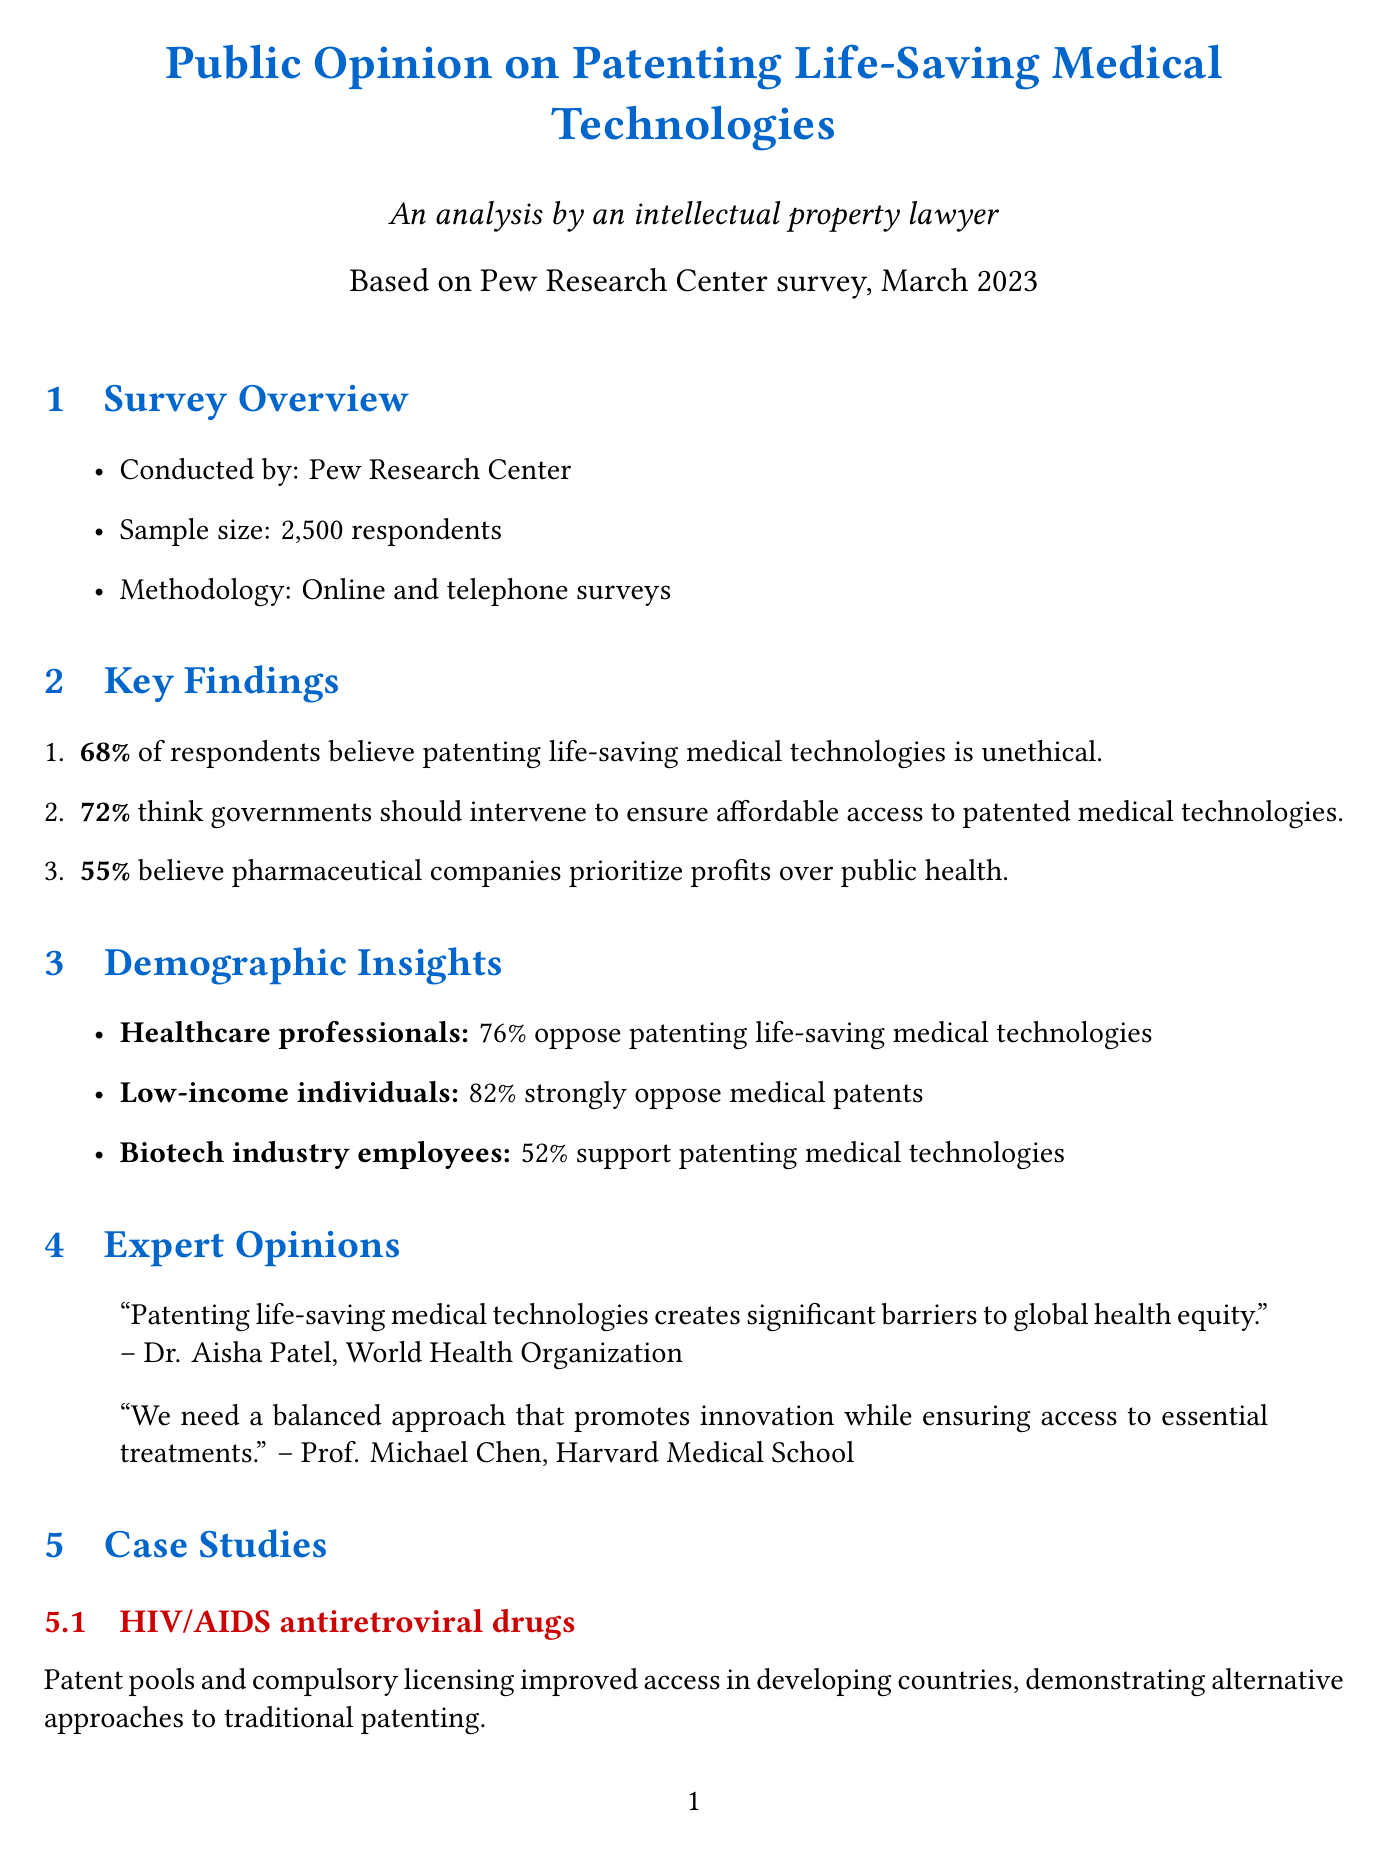what is the title of the report? The title is the first section under "Survey Overview" in the document.
Answer: Public Opinion on Patenting Life-Saving Medical Technologies who conducted the survey? The document names the organization responsible for the survey in the overview section.
Answer: Pew Research Center what percentage of respondents think patenting is unethical? This statistic is included in the "Key Findings" section of the document.
Answer: 68% what did Dr. Aisha Patel state about patenting? The document includes expert opinions, where Dr. Patel's statement is quoted.
Answer: Patenting life-saving medical technologies creates significant barriers to global health equity what was the opinion of low-income individuals on medical patents? The document provides insights into the opinions of specific demographic groups.
Answer: 82% strongly oppose medical patents what are the two proposed policy implications mentioned? The document lists recommendations under the "Policy Implications" section.
Answer: Implement broader compulsory licensing provisions, Establish a global fund to compensate innovators for life-saving technologies which case limited the scope of medical patents? The legal precedents section of the document outlines important cases related to patenting.
Answer: Association for Molecular Pathology v. Myriad Genetics how many total respondents participated in the survey? The total sample size is provided in the "Survey Overview" section.
Answer: 2500 